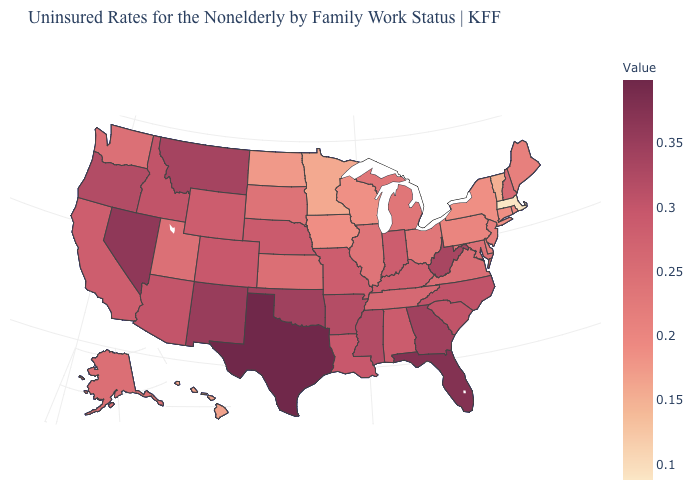Does the map have missing data?
Write a very short answer. No. Among the states that border Oklahoma , does Texas have the highest value?
Answer briefly. Yes. Is the legend a continuous bar?
Quick response, please. Yes. Which states have the highest value in the USA?
Answer briefly. Texas. Does New Jersey have a lower value than Hawaii?
Concise answer only. No. Is the legend a continuous bar?
Answer briefly. Yes. Which states hav the highest value in the South?
Concise answer only. Texas. Which states have the lowest value in the USA?
Quick response, please. Massachusetts. 